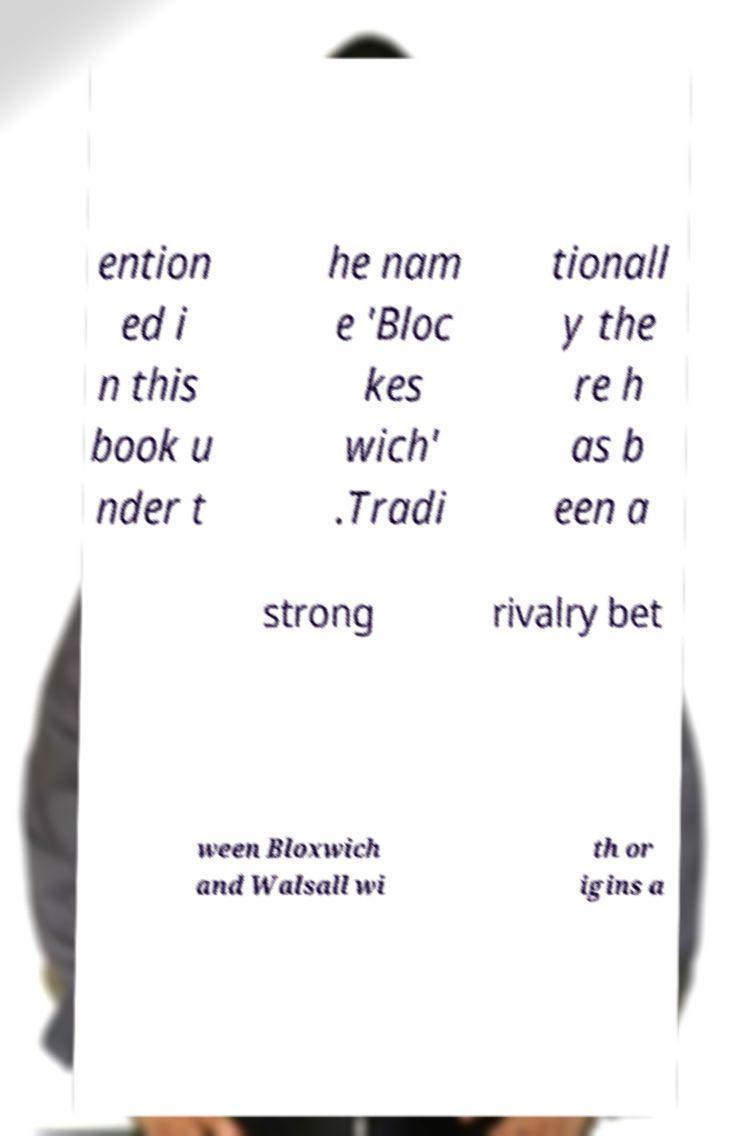What messages or text are displayed in this image? I need them in a readable, typed format. ention ed i n this book u nder t he nam e 'Bloc kes wich' .Tradi tionall y the re h as b een a strong rivalry bet ween Bloxwich and Walsall wi th or igins a 